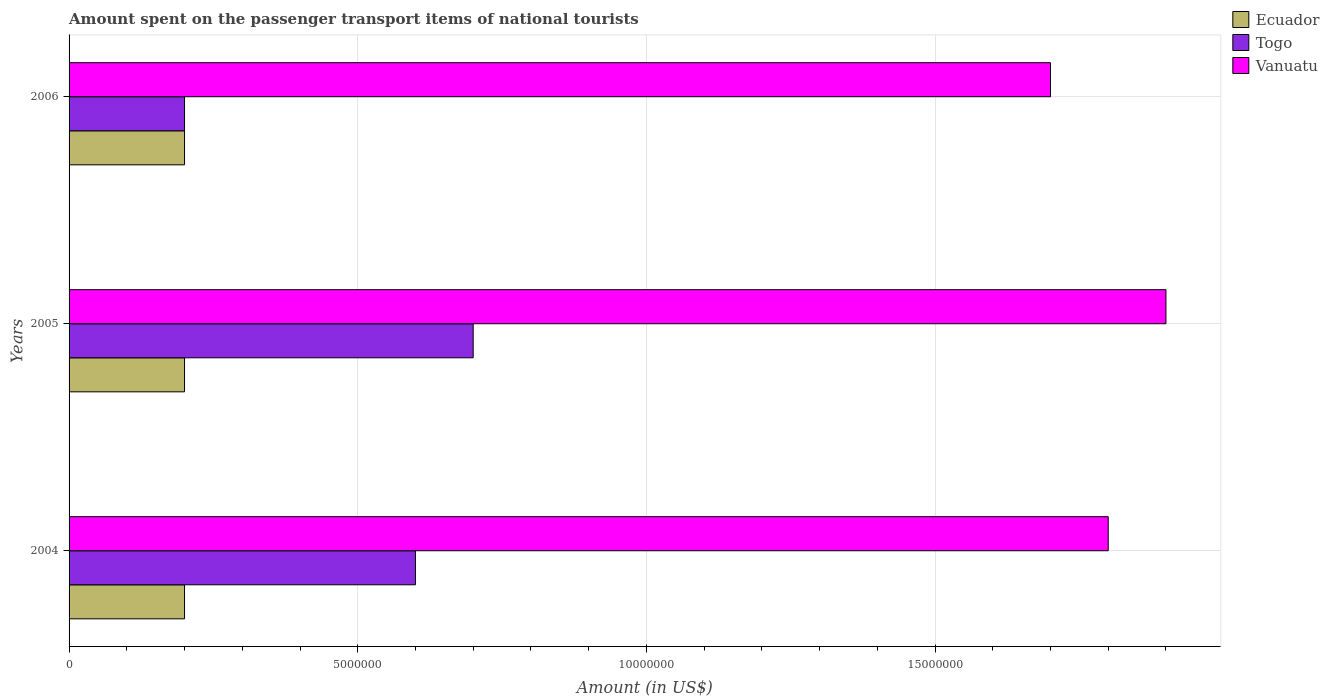How many different coloured bars are there?
Offer a very short reply. 3. Are the number of bars per tick equal to the number of legend labels?
Your response must be concise. Yes. Are the number of bars on each tick of the Y-axis equal?
Provide a short and direct response. Yes. How many bars are there on the 1st tick from the bottom?
Offer a very short reply. 3. What is the label of the 2nd group of bars from the top?
Offer a terse response. 2005. In how many cases, is the number of bars for a given year not equal to the number of legend labels?
Your response must be concise. 0. What is the amount spent on the passenger transport items of national tourists in Vanuatu in 2006?
Offer a very short reply. 1.70e+07. In which year was the amount spent on the passenger transport items of national tourists in Ecuador minimum?
Your answer should be compact. 2004. What is the total amount spent on the passenger transport items of national tourists in Ecuador in the graph?
Provide a short and direct response. 6.00e+06. What is the difference between the amount spent on the passenger transport items of national tourists in Ecuador in 2004 and that in 2006?
Make the answer very short. 0. What is the difference between the amount spent on the passenger transport items of national tourists in Vanuatu in 2004 and the amount spent on the passenger transport items of national tourists in Togo in 2006?
Provide a succinct answer. 1.60e+07. What is the average amount spent on the passenger transport items of national tourists in Vanuatu per year?
Make the answer very short. 1.80e+07. In the year 2006, what is the difference between the amount spent on the passenger transport items of national tourists in Ecuador and amount spent on the passenger transport items of national tourists in Togo?
Keep it short and to the point. 0. In how many years, is the amount spent on the passenger transport items of national tourists in Togo greater than 5000000 US$?
Offer a terse response. 2. What is the ratio of the amount spent on the passenger transport items of national tourists in Togo in 2005 to that in 2006?
Your answer should be compact. 3.5. Is the difference between the amount spent on the passenger transport items of national tourists in Ecuador in 2004 and 2006 greater than the difference between the amount spent on the passenger transport items of national tourists in Togo in 2004 and 2006?
Keep it short and to the point. No. In how many years, is the amount spent on the passenger transport items of national tourists in Vanuatu greater than the average amount spent on the passenger transport items of national tourists in Vanuatu taken over all years?
Offer a very short reply. 1. Is the sum of the amount spent on the passenger transport items of national tourists in Togo in 2004 and 2005 greater than the maximum amount spent on the passenger transport items of national tourists in Vanuatu across all years?
Provide a succinct answer. No. What does the 2nd bar from the top in 2004 represents?
Offer a very short reply. Togo. What does the 2nd bar from the bottom in 2006 represents?
Provide a short and direct response. Togo. Is it the case that in every year, the sum of the amount spent on the passenger transport items of national tourists in Ecuador and amount spent on the passenger transport items of national tourists in Vanuatu is greater than the amount spent on the passenger transport items of national tourists in Togo?
Your answer should be compact. Yes. How many bars are there?
Provide a short and direct response. 9. Are the values on the major ticks of X-axis written in scientific E-notation?
Provide a short and direct response. No. Does the graph contain any zero values?
Your answer should be very brief. No. Does the graph contain grids?
Your answer should be very brief. Yes. How many legend labels are there?
Make the answer very short. 3. What is the title of the graph?
Give a very brief answer. Amount spent on the passenger transport items of national tourists. Does "Curacao" appear as one of the legend labels in the graph?
Keep it short and to the point. No. What is the label or title of the X-axis?
Your answer should be compact. Amount (in US$). What is the Amount (in US$) of Ecuador in 2004?
Offer a terse response. 2.00e+06. What is the Amount (in US$) in Vanuatu in 2004?
Ensure brevity in your answer.  1.80e+07. What is the Amount (in US$) of Togo in 2005?
Your answer should be compact. 7.00e+06. What is the Amount (in US$) of Vanuatu in 2005?
Give a very brief answer. 1.90e+07. What is the Amount (in US$) in Vanuatu in 2006?
Make the answer very short. 1.70e+07. Across all years, what is the maximum Amount (in US$) of Vanuatu?
Your answer should be very brief. 1.90e+07. Across all years, what is the minimum Amount (in US$) in Ecuador?
Your response must be concise. 2.00e+06. Across all years, what is the minimum Amount (in US$) in Togo?
Provide a succinct answer. 2.00e+06. Across all years, what is the minimum Amount (in US$) of Vanuatu?
Keep it short and to the point. 1.70e+07. What is the total Amount (in US$) of Ecuador in the graph?
Give a very brief answer. 6.00e+06. What is the total Amount (in US$) in Togo in the graph?
Provide a short and direct response. 1.50e+07. What is the total Amount (in US$) in Vanuatu in the graph?
Make the answer very short. 5.40e+07. What is the difference between the Amount (in US$) of Togo in 2004 and that in 2005?
Your answer should be very brief. -1.00e+06. What is the difference between the Amount (in US$) of Vanuatu in 2004 and that in 2005?
Keep it short and to the point. -1.00e+06. What is the difference between the Amount (in US$) in Ecuador in 2004 and that in 2006?
Make the answer very short. 0. What is the difference between the Amount (in US$) of Togo in 2004 and that in 2006?
Offer a terse response. 4.00e+06. What is the difference between the Amount (in US$) in Ecuador in 2005 and that in 2006?
Give a very brief answer. 0. What is the difference between the Amount (in US$) of Vanuatu in 2005 and that in 2006?
Give a very brief answer. 2.00e+06. What is the difference between the Amount (in US$) of Ecuador in 2004 and the Amount (in US$) of Togo in 2005?
Make the answer very short. -5.00e+06. What is the difference between the Amount (in US$) of Ecuador in 2004 and the Amount (in US$) of Vanuatu in 2005?
Your response must be concise. -1.70e+07. What is the difference between the Amount (in US$) of Togo in 2004 and the Amount (in US$) of Vanuatu in 2005?
Provide a succinct answer. -1.30e+07. What is the difference between the Amount (in US$) of Ecuador in 2004 and the Amount (in US$) of Togo in 2006?
Provide a succinct answer. 0. What is the difference between the Amount (in US$) in Ecuador in 2004 and the Amount (in US$) in Vanuatu in 2006?
Keep it short and to the point. -1.50e+07. What is the difference between the Amount (in US$) of Togo in 2004 and the Amount (in US$) of Vanuatu in 2006?
Ensure brevity in your answer.  -1.10e+07. What is the difference between the Amount (in US$) of Ecuador in 2005 and the Amount (in US$) of Vanuatu in 2006?
Your answer should be very brief. -1.50e+07. What is the difference between the Amount (in US$) of Togo in 2005 and the Amount (in US$) of Vanuatu in 2006?
Your response must be concise. -1.00e+07. What is the average Amount (in US$) of Vanuatu per year?
Your answer should be compact. 1.80e+07. In the year 2004, what is the difference between the Amount (in US$) in Ecuador and Amount (in US$) in Vanuatu?
Keep it short and to the point. -1.60e+07. In the year 2004, what is the difference between the Amount (in US$) of Togo and Amount (in US$) of Vanuatu?
Offer a terse response. -1.20e+07. In the year 2005, what is the difference between the Amount (in US$) in Ecuador and Amount (in US$) in Togo?
Offer a very short reply. -5.00e+06. In the year 2005, what is the difference between the Amount (in US$) in Ecuador and Amount (in US$) in Vanuatu?
Offer a very short reply. -1.70e+07. In the year 2005, what is the difference between the Amount (in US$) of Togo and Amount (in US$) of Vanuatu?
Keep it short and to the point. -1.20e+07. In the year 2006, what is the difference between the Amount (in US$) in Ecuador and Amount (in US$) in Togo?
Make the answer very short. 0. In the year 2006, what is the difference between the Amount (in US$) of Ecuador and Amount (in US$) of Vanuatu?
Ensure brevity in your answer.  -1.50e+07. In the year 2006, what is the difference between the Amount (in US$) of Togo and Amount (in US$) of Vanuatu?
Your response must be concise. -1.50e+07. What is the ratio of the Amount (in US$) in Togo in 2004 to that in 2005?
Offer a very short reply. 0.86. What is the ratio of the Amount (in US$) in Vanuatu in 2004 to that in 2005?
Give a very brief answer. 0.95. What is the ratio of the Amount (in US$) in Vanuatu in 2004 to that in 2006?
Offer a terse response. 1.06. What is the ratio of the Amount (in US$) in Ecuador in 2005 to that in 2006?
Provide a short and direct response. 1. What is the ratio of the Amount (in US$) in Togo in 2005 to that in 2006?
Your response must be concise. 3.5. What is the ratio of the Amount (in US$) of Vanuatu in 2005 to that in 2006?
Keep it short and to the point. 1.12. What is the difference between the highest and the second highest Amount (in US$) in Togo?
Your answer should be compact. 1.00e+06. What is the difference between the highest and the lowest Amount (in US$) of Ecuador?
Your answer should be very brief. 0. What is the difference between the highest and the lowest Amount (in US$) of Togo?
Provide a succinct answer. 5.00e+06. What is the difference between the highest and the lowest Amount (in US$) in Vanuatu?
Ensure brevity in your answer.  2.00e+06. 